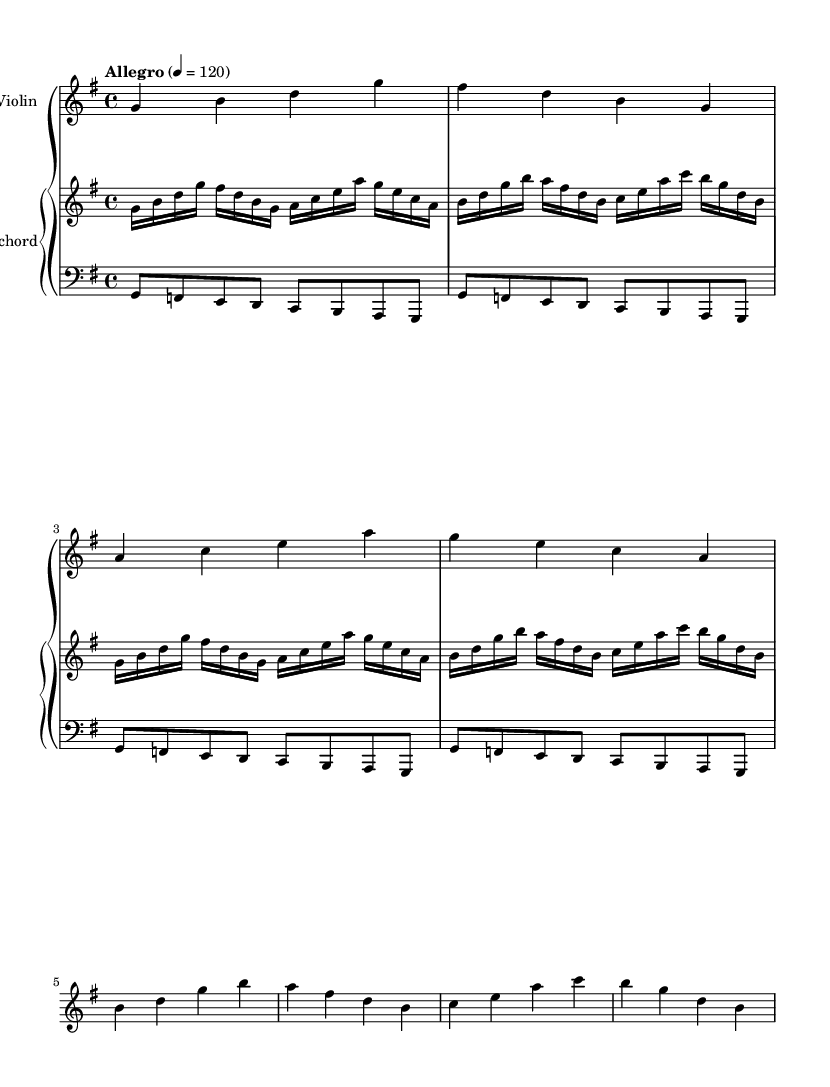What is the key signature of this music? The key signature is G major, which includes one sharp (F#). The presence of the F# in the melody indicates this key.
Answer: G major What is the time signature? The time signature is indicated at the beginning of the score. It shows 4/4, meaning there are four beats in a measure and a quarter note gets one beat.
Answer: 4/4 What is the tempo marking of this piece? The tempo marking is shown at the start of the score, stating "Allegro," which indicates a fast, lively tempo. The metronome marking of quarter note equals 120 confirms the quick pace.
Answer: Allegro How many measures are in the violin part? The violin part is presented in 8 measures. Counting the individual groups in the music notation, we confirm this total.
Answer: 8 What dynamic markings are present in the piece? There are no explicit dynamic markings indicated on the score. The absence of dynamics suggests a general performance without specified volume instructions.
Answer: None Is the composition suitable for a solo instrument? This composition features both violin and harpsichord parts, suggesting it's meant for more than one instrument. The accompanying harpsichord part works with the violin, enhancing the texture of the piece.
Answer: No 